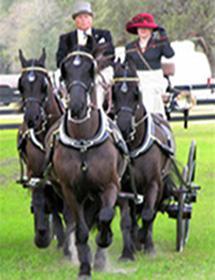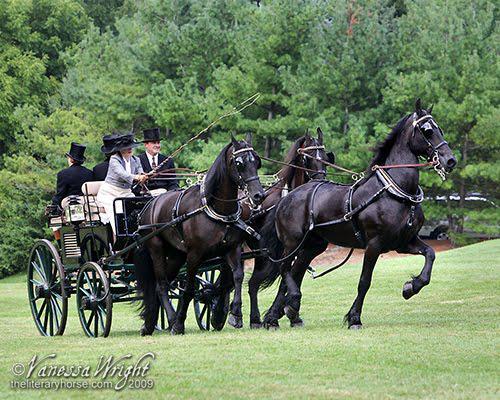The first image is the image on the left, the second image is the image on the right. Considering the images on both sides, is "The horses in the image on the right are pulling a red carriage." valid? Answer yes or no. No. 